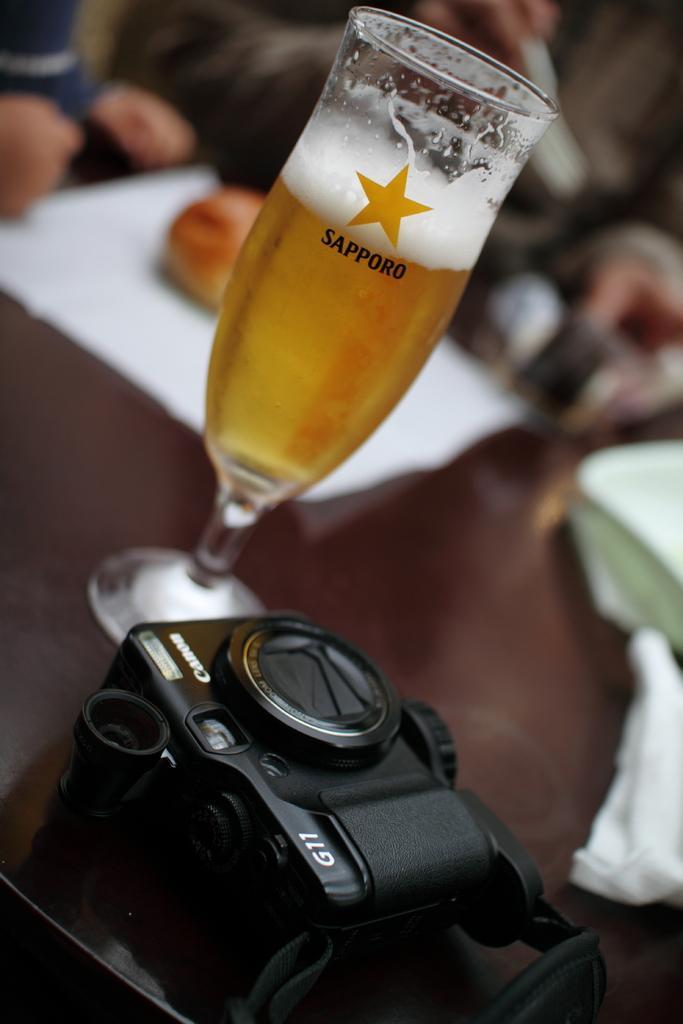Please provide a concise description of this image. In this picture I can see the camera, wine glass, paper, plates and other objects on the table. In the back I can see two persons who are sitting on the chair. 